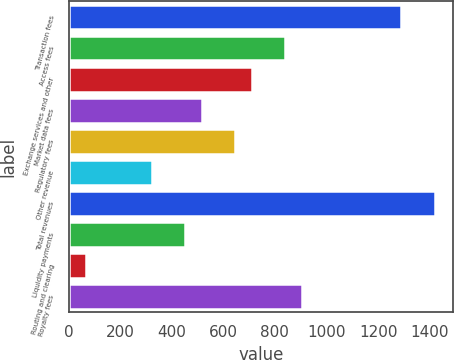Convert chart to OTSL. <chart><loc_0><loc_0><loc_500><loc_500><bar_chart><fcel>Transaction fees<fcel>Access fees<fcel>Exchange services and other<fcel>Market data fees<fcel>Regulatory fees<fcel>Other revenue<fcel>Total revenues<fcel>Liquidity payments<fcel>Routing and clearing<fcel>Royalty fees<nl><fcel>1290.61<fcel>839.67<fcel>710.83<fcel>517.57<fcel>646.41<fcel>324.31<fcel>1419.45<fcel>453.15<fcel>66.63<fcel>904.09<nl></chart> 